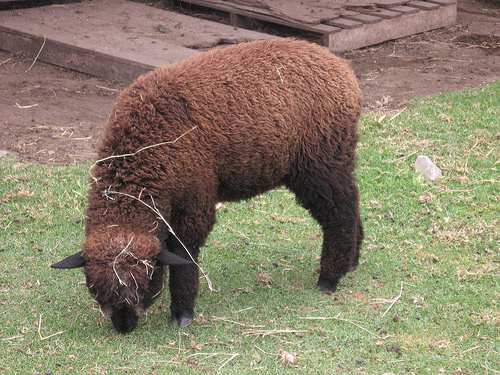What type of animal is this, and can you tell me more about its habitat? This is an image of an alpaca, which is a domesticated species from the camelid family. Alpacas are native to the Andean mountain range of South America, and they typically inhabit high-altitude regions, often over 3,500 meters above sea level. They are known for their thick fleece, which is used to make various woolen goods. 